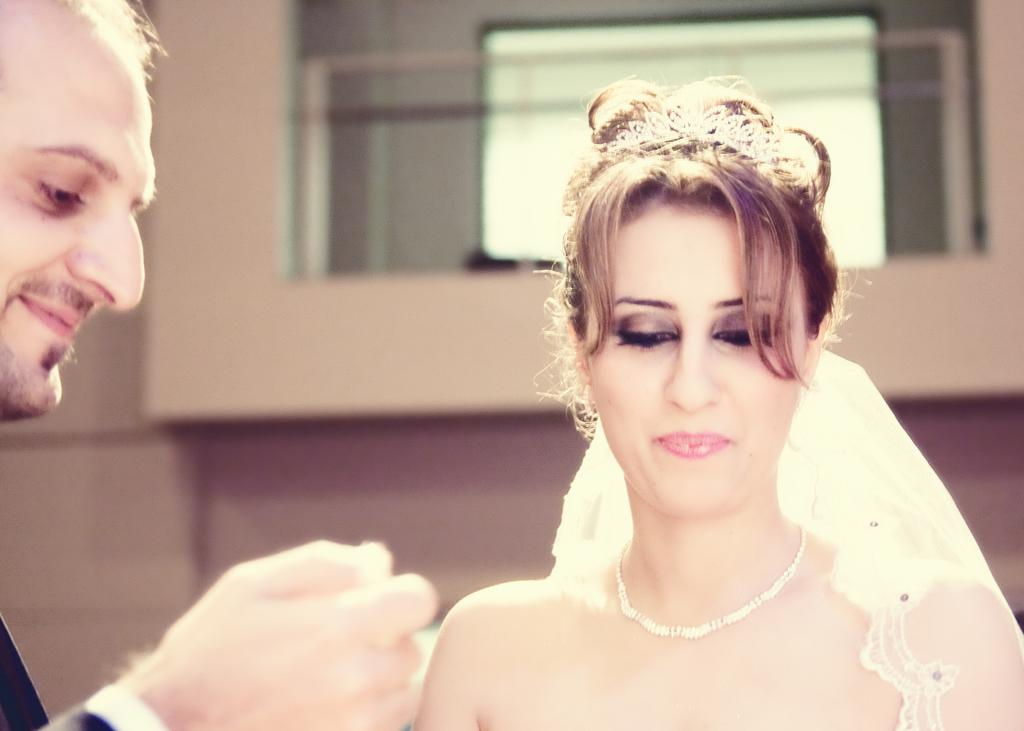Who are the people in the image? There is a man and a woman in the image. What are the people in the image doing? The facts provided do not specify what the man and woman are doing in the image. Can you describe the clothing of the people in the image? The facts provided do not specify the clothing of the man and woman in the image. How many chickens are present in the image? There are no chickens present in the image; it features a man and a woman. What is the national debt of the country depicted in the image? The facts provided do not mention any country or national debt, and the image only features a man and a woman. 